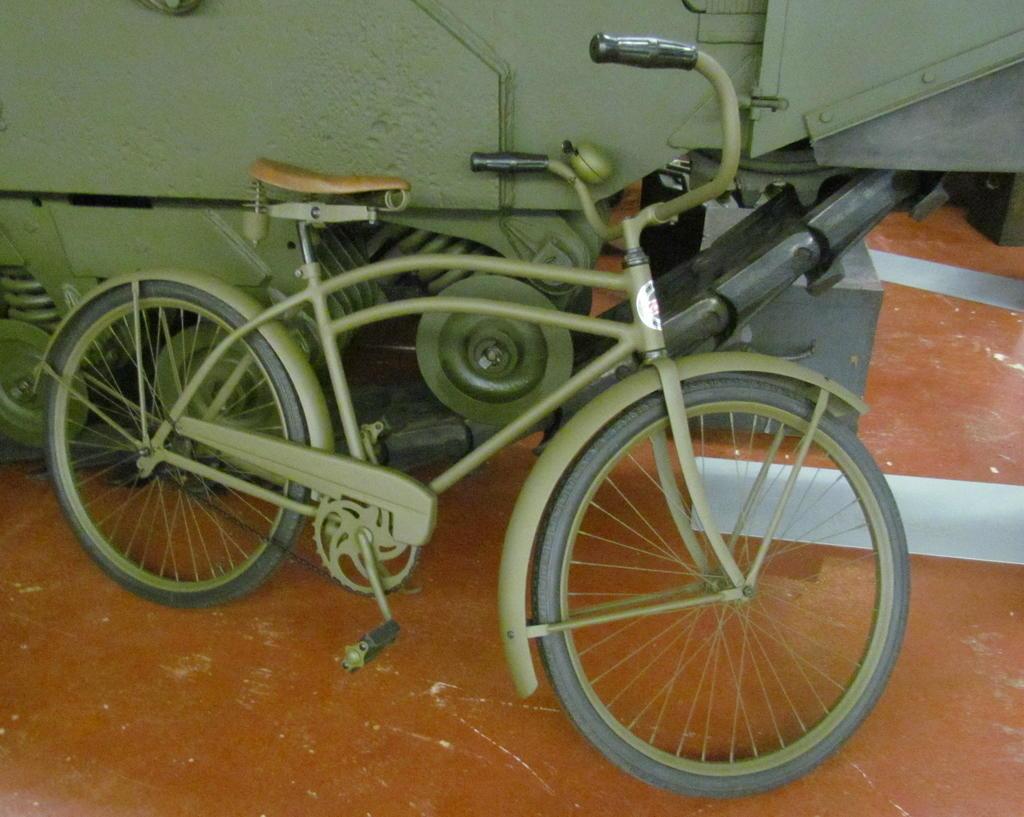Could you give a brief overview of what you see in this image? There is a green bicycle and a vehicle behind it. There is a brown surface. 